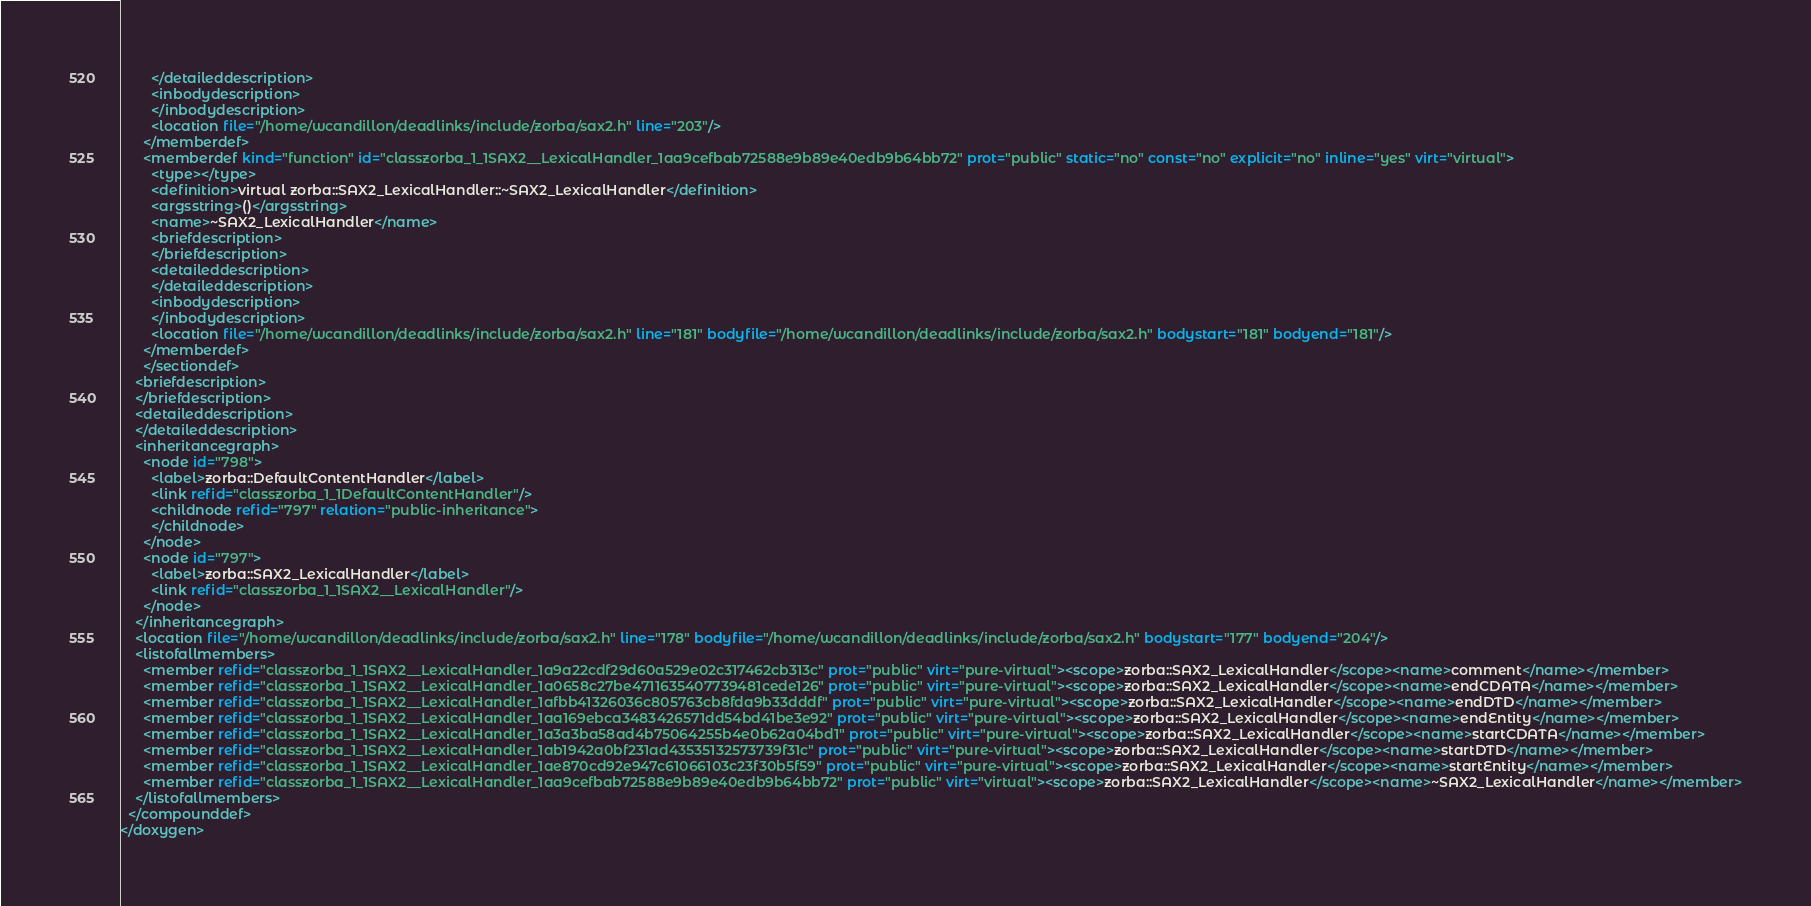Convert code to text. <code><loc_0><loc_0><loc_500><loc_500><_XML_>        </detaileddescription>
        <inbodydescription>
        </inbodydescription>
        <location file="/home/wcandillon/deadlinks/include/zorba/sax2.h" line="203"/>
      </memberdef>
      <memberdef kind="function" id="classzorba_1_1SAX2__LexicalHandler_1aa9cefbab72588e9b89e40edb9b64bb72" prot="public" static="no" const="no" explicit="no" inline="yes" virt="virtual">
        <type></type>
        <definition>virtual zorba::SAX2_LexicalHandler::~SAX2_LexicalHandler</definition>
        <argsstring>()</argsstring>
        <name>~SAX2_LexicalHandler</name>
        <briefdescription>
        </briefdescription>
        <detaileddescription>
        </detaileddescription>
        <inbodydescription>
        </inbodydescription>
        <location file="/home/wcandillon/deadlinks/include/zorba/sax2.h" line="181" bodyfile="/home/wcandillon/deadlinks/include/zorba/sax2.h" bodystart="181" bodyend="181"/>
      </memberdef>
      </sectiondef>
    <briefdescription>
    </briefdescription>
    <detaileddescription>
    </detaileddescription>
    <inheritancegraph>
      <node id="798">
        <label>zorba::DefaultContentHandler</label>
        <link refid="classzorba_1_1DefaultContentHandler"/>
        <childnode refid="797" relation="public-inheritance">
        </childnode>
      </node>
      <node id="797">
        <label>zorba::SAX2_LexicalHandler</label>
        <link refid="classzorba_1_1SAX2__LexicalHandler"/>
      </node>
    </inheritancegraph>
    <location file="/home/wcandillon/deadlinks/include/zorba/sax2.h" line="178" bodyfile="/home/wcandillon/deadlinks/include/zorba/sax2.h" bodystart="177" bodyend="204"/>
    <listofallmembers>
      <member refid="classzorba_1_1SAX2__LexicalHandler_1a9a22cdf29d60a529e02c317462cb313c" prot="public" virt="pure-virtual"><scope>zorba::SAX2_LexicalHandler</scope><name>comment</name></member>
      <member refid="classzorba_1_1SAX2__LexicalHandler_1a0658c27be4711635407739481cede126" prot="public" virt="pure-virtual"><scope>zorba::SAX2_LexicalHandler</scope><name>endCDATA</name></member>
      <member refid="classzorba_1_1SAX2__LexicalHandler_1afbb41326036c805763cb8fda9b33dddf" prot="public" virt="pure-virtual"><scope>zorba::SAX2_LexicalHandler</scope><name>endDTD</name></member>
      <member refid="classzorba_1_1SAX2__LexicalHandler_1aa169ebca3483426571dd54bd41be3e92" prot="public" virt="pure-virtual"><scope>zorba::SAX2_LexicalHandler</scope><name>endEntity</name></member>
      <member refid="classzorba_1_1SAX2__LexicalHandler_1a3a3ba58ad4b75064255b4e0b62a04bd1" prot="public" virt="pure-virtual"><scope>zorba::SAX2_LexicalHandler</scope><name>startCDATA</name></member>
      <member refid="classzorba_1_1SAX2__LexicalHandler_1ab1942a0bf231ad43535132573739f31c" prot="public" virt="pure-virtual"><scope>zorba::SAX2_LexicalHandler</scope><name>startDTD</name></member>
      <member refid="classzorba_1_1SAX2__LexicalHandler_1ae870cd92e947c61066103c23f30b5f59" prot="public" virt="pure-virtual"><scope>zorba::SAX2_LexicalHandler</scope><name>startEntity</name></member>
      <member refid="classzorba_1_1SAX2__LexicalHandler_1aa9cefbab72588e9b89e40edb9b64bb72" prot="public" virt="virtual"><scope>zorba::SAX2_LexicalHandler</scope><name>~SAX2_LexicalHandler</name></member>
    </listofallmembers>
  </compounddef>
</doxygen>
</code> 